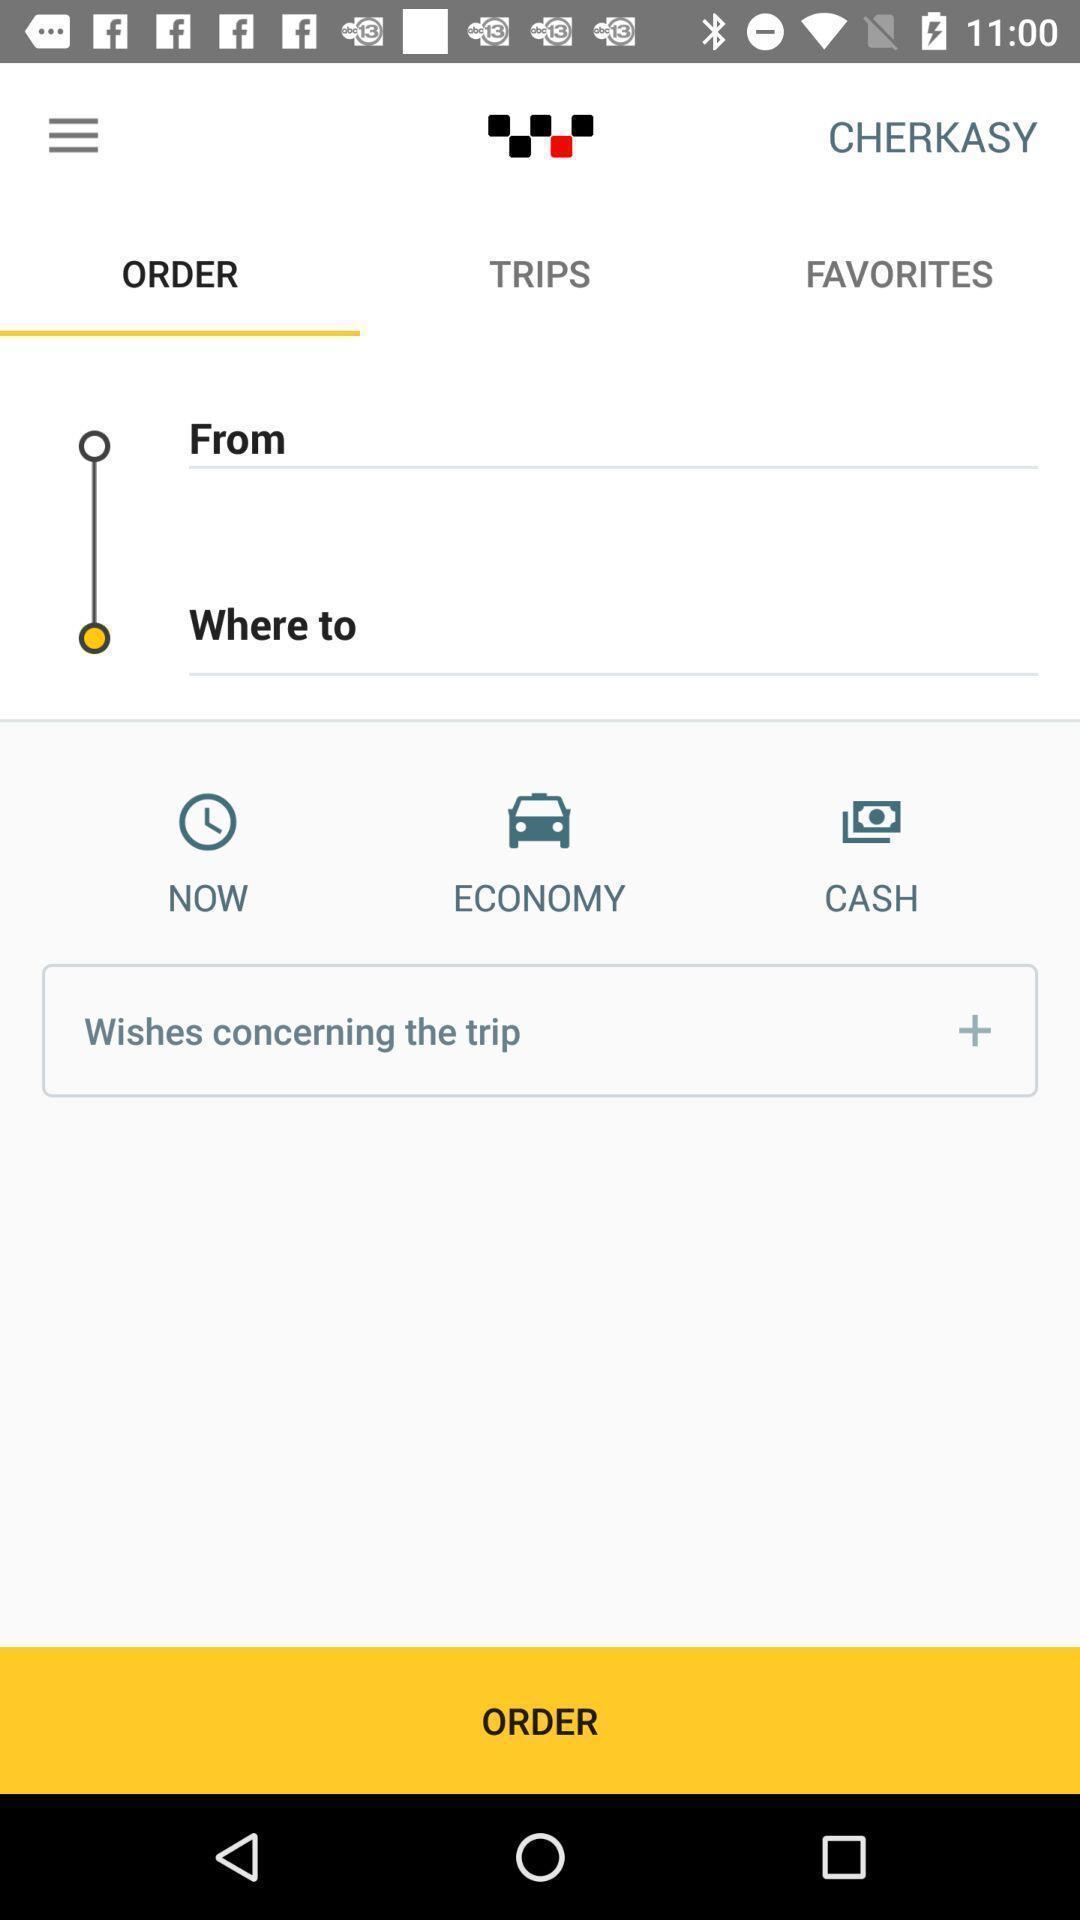Describe the visual elements of this screenshot. Page of a travel service app. 